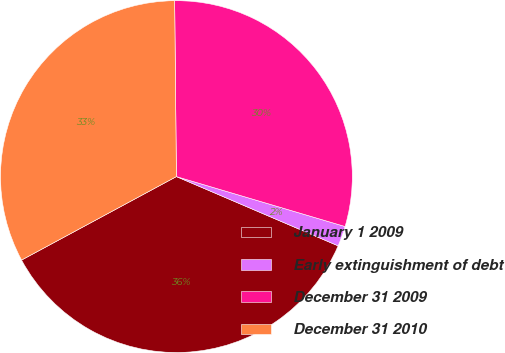<chart> <loc_0><loc_0><loc_500><loc_500><pie_chart><fcel>January 1 2009<fcel>Early extinguishment of debt<fcel>December 31 2009<fcel>December 31 2010<nl><fcel>35.69%<fcel>1.86%<fcel>29.74%<fcel>32.71%<nl></chart> 